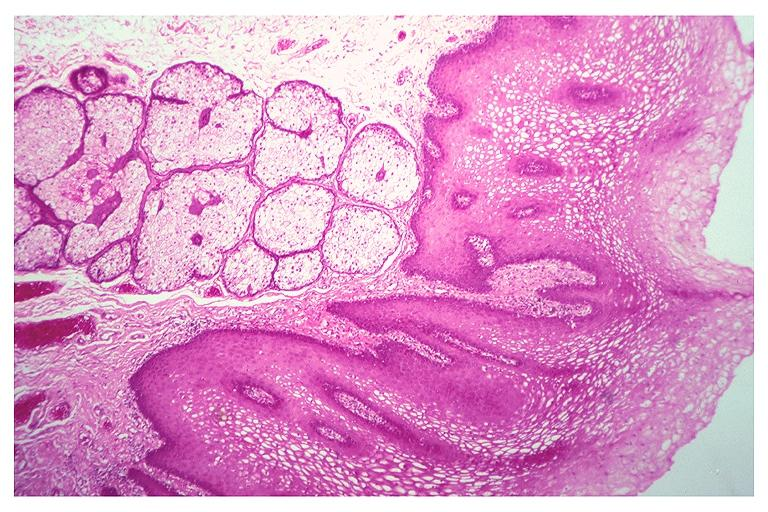does this image show fordyce granules?
Answer the question using a single word or phrase. Yes 